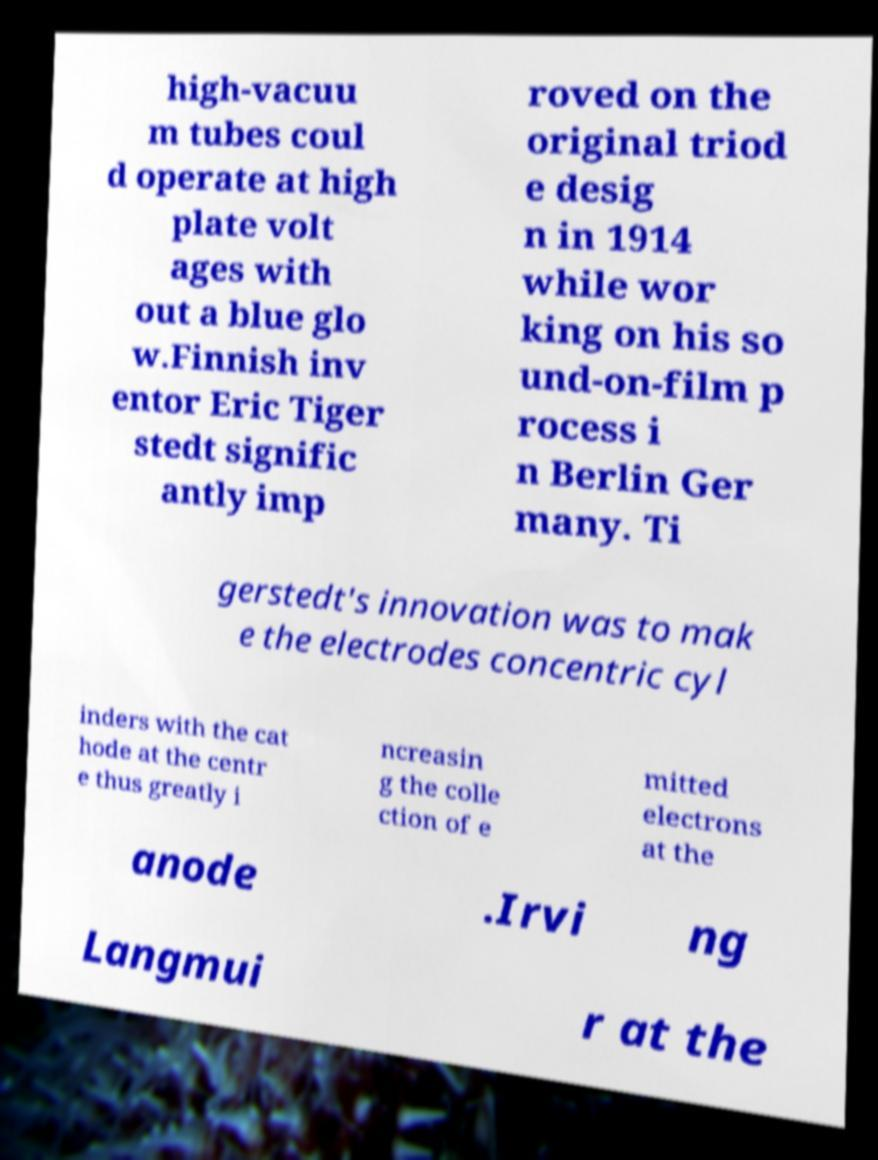Could you assist in decoding the text presented in this image and type it out clearly? high-vacuu m tubes coul d operate at high plate volt ages with out a blue glo w.Finnish inv entor Eric Tiger stedt signific antly imp roved on the original triod e desig n in 1914 while wor king on his so und-on-film p rocess i n Berlin Ger many. Ti gerstedt's innovation was to mak e the electrodes concentric cyl inders with the cat hode at the centr e thus greatly i ncreasin g the colle ction of e mitted electrons at the anode .Irvi ng Langmui r at the 